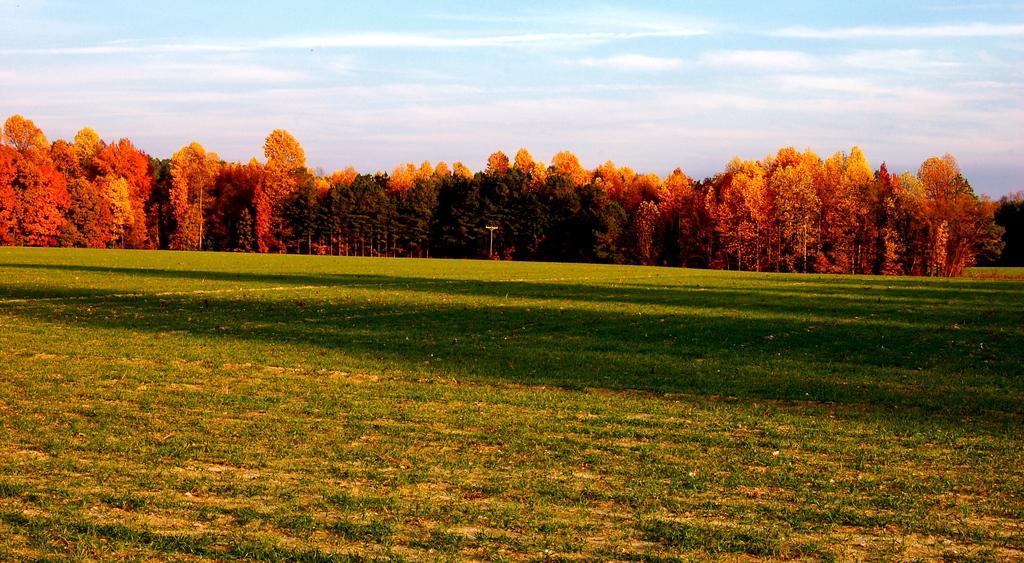Please provide a concise description of this image. In this image we can see a ground with grass. At the center of the image there are trees. In the background there is a sky. 